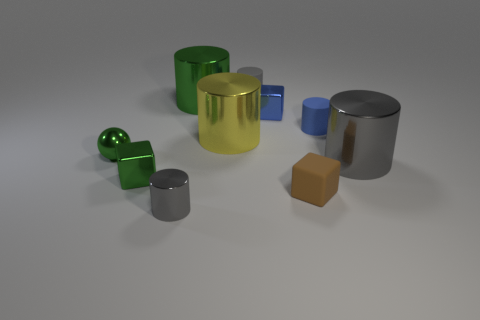What number of objects are purple rubber balls or tiny blue cylinders?
Give a very brief answer. 1. What shape is the tiny shiny object to the right of the gray rubber cylinder?
Provide a succinct answer. Cube. The small cylinder that is the same material as the sphere is what color?
Provide a short and direct response. Gray. There is a green thing that is the same shape as the large yellow metallic thing; what is it made of?
Offer a terse response. Metal. What shape is the tiny blue shiny object?
Your answer should be compact. Cube. There is a gray thing that is on the left side of the large gray metal cylinder and behind the tiny green cube; what material is it?
Offer a very short reply. Rubber. What is the shape of the large green thing that is made of the same material as the small green sphere?
Provide a succinct answer. Cylinder. There is a yellow cylinder that is made of the same material as the small ball; what is its size?
Provide a short and direct response. Large. There is a tiny rubber thing that is both in front of the green metallic cylinder and behind the tiny green shiny ball; what shape is it?
Your response must be concise. Cylinder. What size is the metal cube that is behind the big cylinder that is on the right side of the gray rubber object?
Your answer should be compact. Small. 